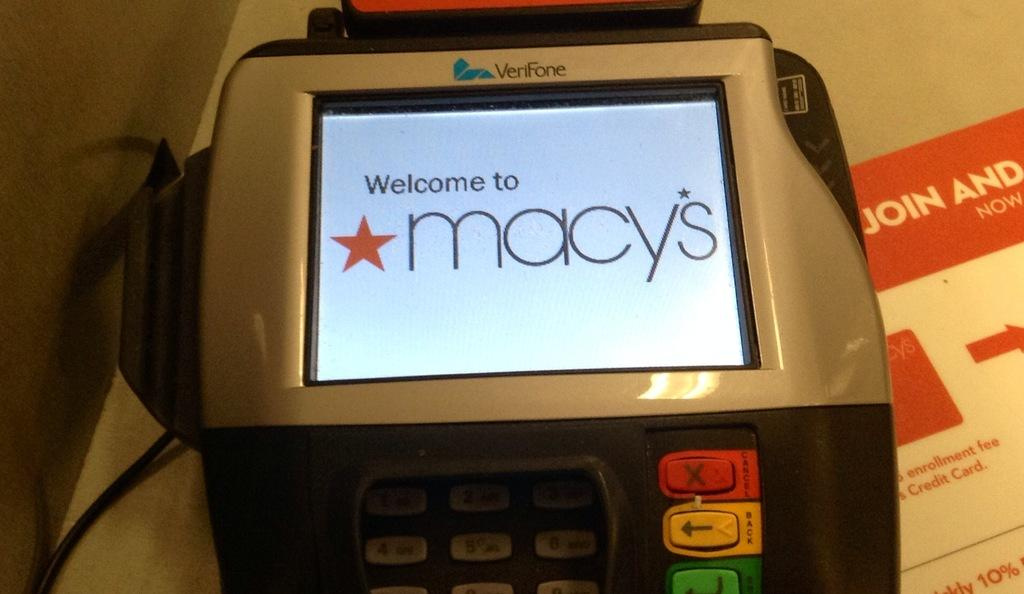What is the main object in the image? There is a machine in the image. Can you describe any additional features of the image? There is a cable in the image. How many cacti can be seen in the image? There are no cacti present in the image. What are the girls doing in the image? There are no girls present in the image. What role does the minister play in the image? There is no minister present in the image. 